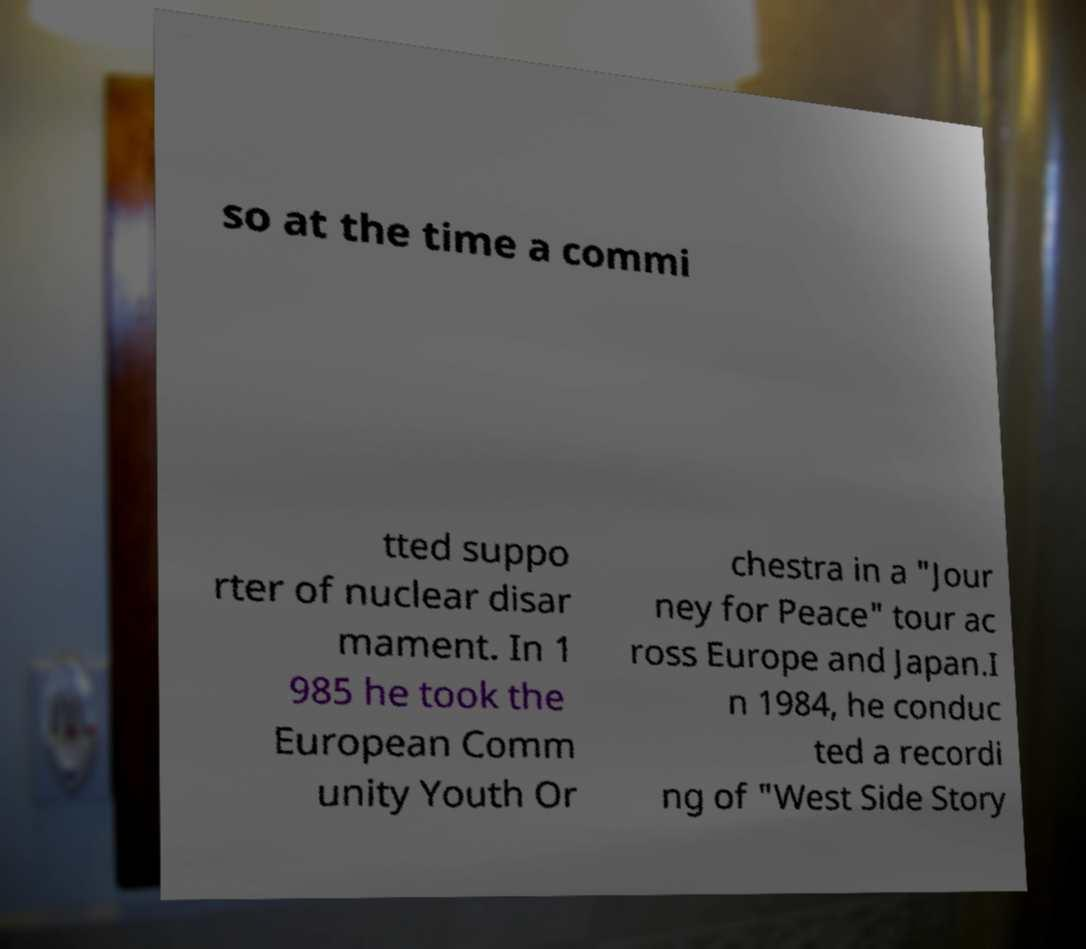Can you accurately transcribe the text from the provided image for me? so at the time a commi tted suppo rter of nuclear disar mament. In 1 985 he took the European Comm unity Youth Or chestra in a "Jour ney for Peace" tour ac ross Europe and Japan.I n 1984, he conduc ted a recordi ng of "West Side Story 